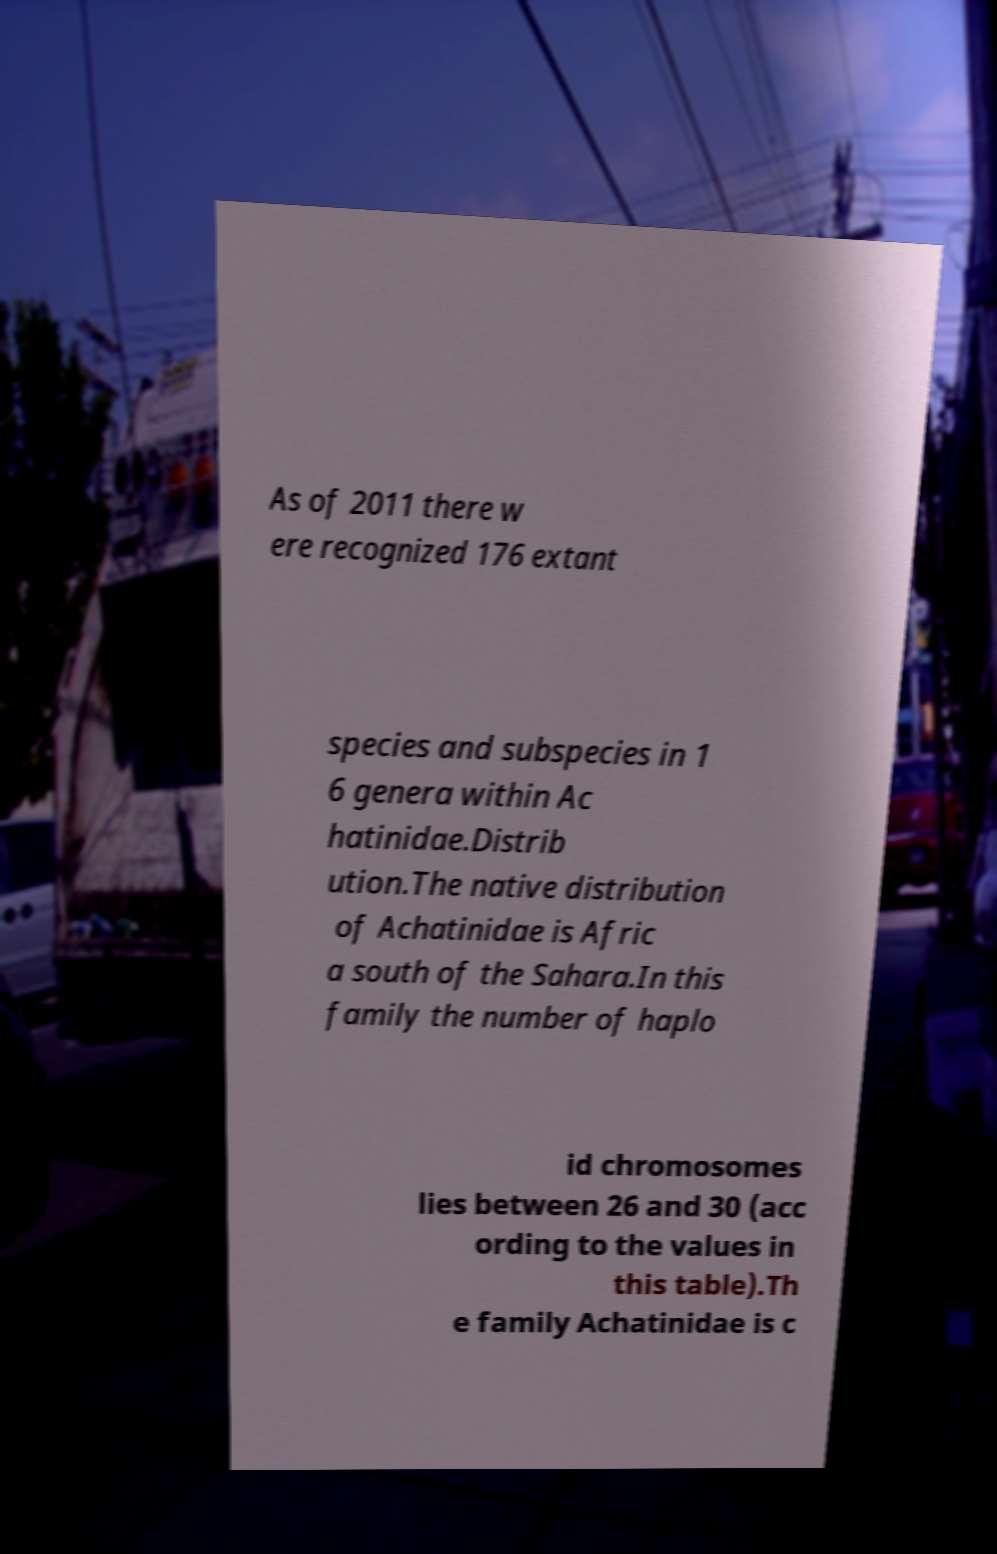Can you accurately transcribe the text from the provided image for me? As of 2011 there w ere recognized 176 extant species and subspecies in 1 6 genera within Ac hatinidae.Distrib ution.The native distribution of Achatinidae is Afric a south of the Sahara.In this family the number of haplo id chromosomes lies between 26 and 30 (acc ording to the values in this table).Th e family Achatinidae is c 